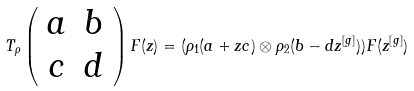Convert formula to latex. <formula><loc_0><loc_0><loc_500><loc_500>T _ { \rho } \left ( \begin{array} { c c } a & b \\ c & d \end{array} \right ) F ( z ) = ( \rho _ { 1 } ( a + z c ) \otimes \rho _ { 2 } ( b - d z ^ { [ g ] } ) ) F ( z ^ { [ g ] } )</formula> 